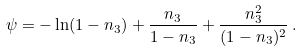Convert formula to latex. <formula><loc_0><loc_0><loc_500><loc_500>\psi = - \ln ( 1 - n _ { 3 } ) + \frac { n _ { 3 } } { 1 - n _ { 3 } } + \frac { n _ { 3 } ^ { 2 } } { ( 1 - n _ { 3 } ) ^ { 2 } } \, .</formula> 